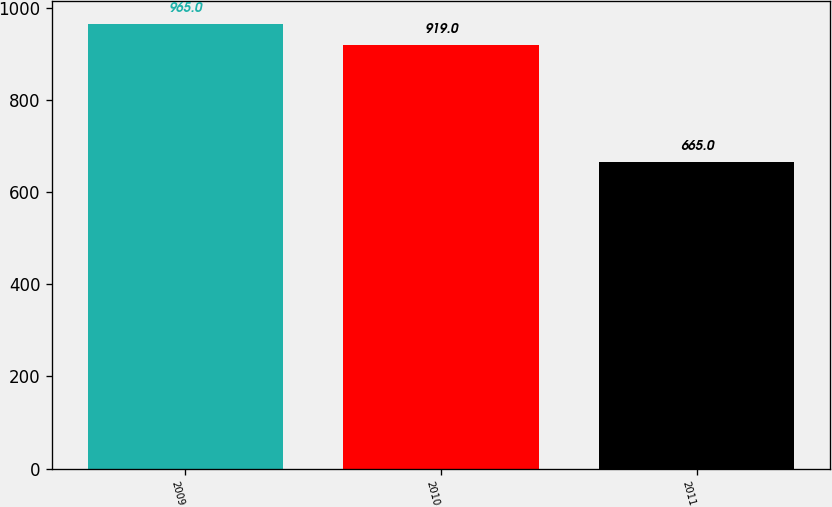<chart> <loc_0><loc_0><loc_500><loc_500><bar_chart><fcel>2009<fcel>2010<fcel>2011<nl><fcel>965<fcel>919<fcel>665<nl></chart> 